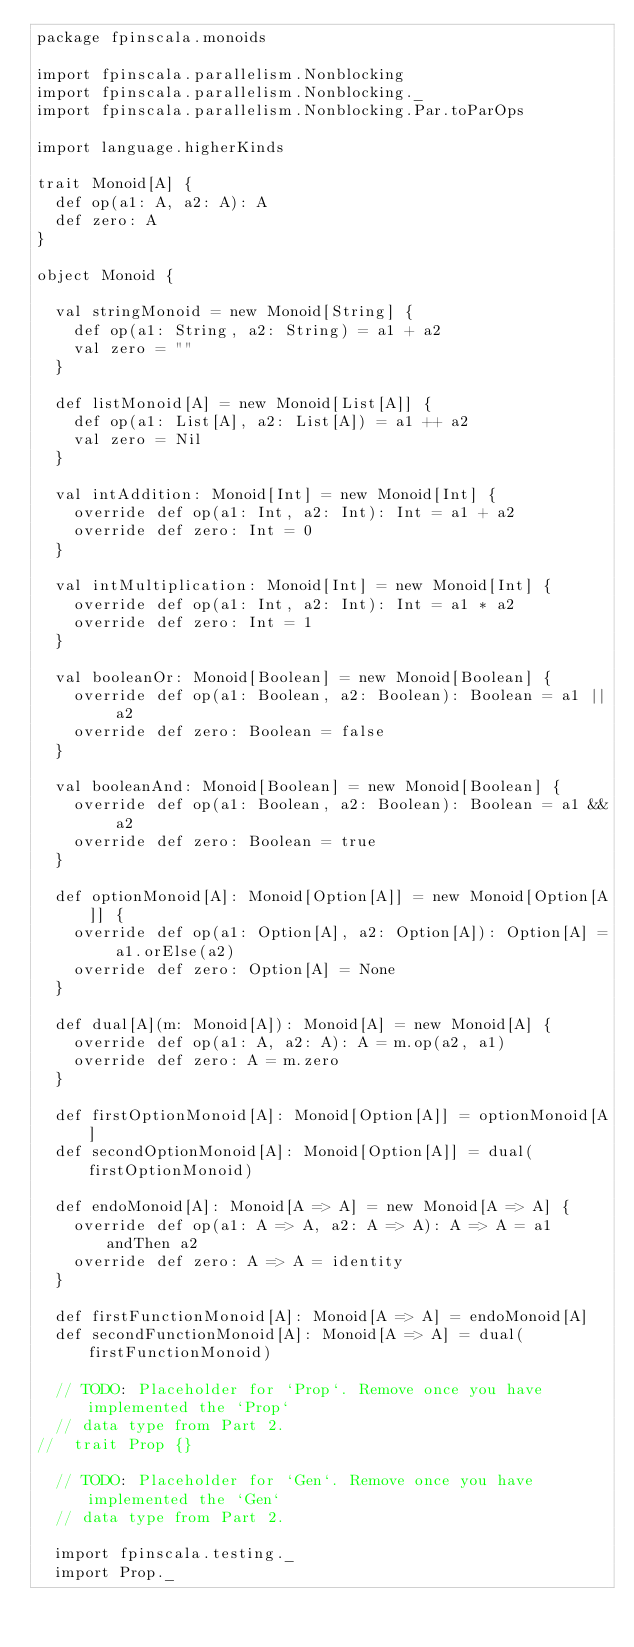Convert code to text. <code><loc_0><loc_0><loc_500><loc_500><_Scala_>package fpinscala.monoids

import fpinscala.parallelism.Nonblocking
import fpinscala.parallelism.Nonblocking._
import fpinscala.parallelism.Nonblocking.Par.toParOps

import language.higherKinds

trait Monoid[A] {
  def op(a1: A, a2: A): A
  def zero: A
}

object Monoid {

  val stringMonoid = new Monoid[String] {
    def op(a1: String, a2: String) = a1 + a2
    val zero = ""
  }

  def listMonoid[A] = new Monoid[List[A]] {
    def op(a1: List[A], a2: List[A]) = a1 ++ a2
    val zero = Nil
  }

  val intAddition: Monoid[Int] = new Monoid[Int] {
    override def op(a1: Int, a2: Int): Int = a1 + a2
    override def zero: Int = 0
  }

  val intMultiplication: Monoid[Int] = new Monoid[Int] {
    override def op(a1: Int, a2: Int): Int = a1 * a2
    override def zero: Int = 1
  }

  val booleanOr: Monoid[Boolean] = new Monoid[Boolean] {
    override def op(a1: Boolean, a2: Boolean): Boolean = a1 || a2
    override def zero: Boolean = false
  }

  val booleanAnd: Monoid[Boolean] = new Monoid[Boolean] {
    override def op(a1: Boolean, a2: Boolean): Boolean = a1 && a2
    override def zero: Boolean = true
  }

  def optionMonoid[A]: Monoid[Option[A]] = new Monoid[Option[A]] {
    override def op(a1: Option[A], a2: Option[A]): Option[A] = a1.orElse(a2)
    override def zero: Option[A] = None
  }

  def dual[A](m: Monoid[A]): Monoid[A] = new Monoid[A] {
    override def op(a1: A, a2: A): A = m.op(a2, a1)
    override def zero: A = m.zero
  }

  def firstOptionMonoid[A]: Monoid[Option[A]] = optionMonoid[A]
  def secondOptionMonoid[A]: Monoid[Option[A]] = dual(firstOptionMonoid)

  def endoMonoid[A]: Monoid[A => A] = new Monoid[A => A] {
    override def op(a1: A => A, a2: A => A): A => A = a1 andThen a2
    override def zero: A => A = identity
  }

  def firstFunctionMonoid[A]: Monoid[A => A] = endoMonoid[A]
  def secondFunctionMonoid[A]: Monoid[A => A] = dual(firstFunctionMonoid)

  // TODO: Placeholder for `Prop`. Remove once you have implemented the `Prop`
  // data type from Part 2.
//  trait Prop {}

  // TODO: Placeholder for `Gen`. Remove once you have implemented the `Gen`
  // data type from Part 2.

  import fpinscala.testing._
  import Prop._</code> 